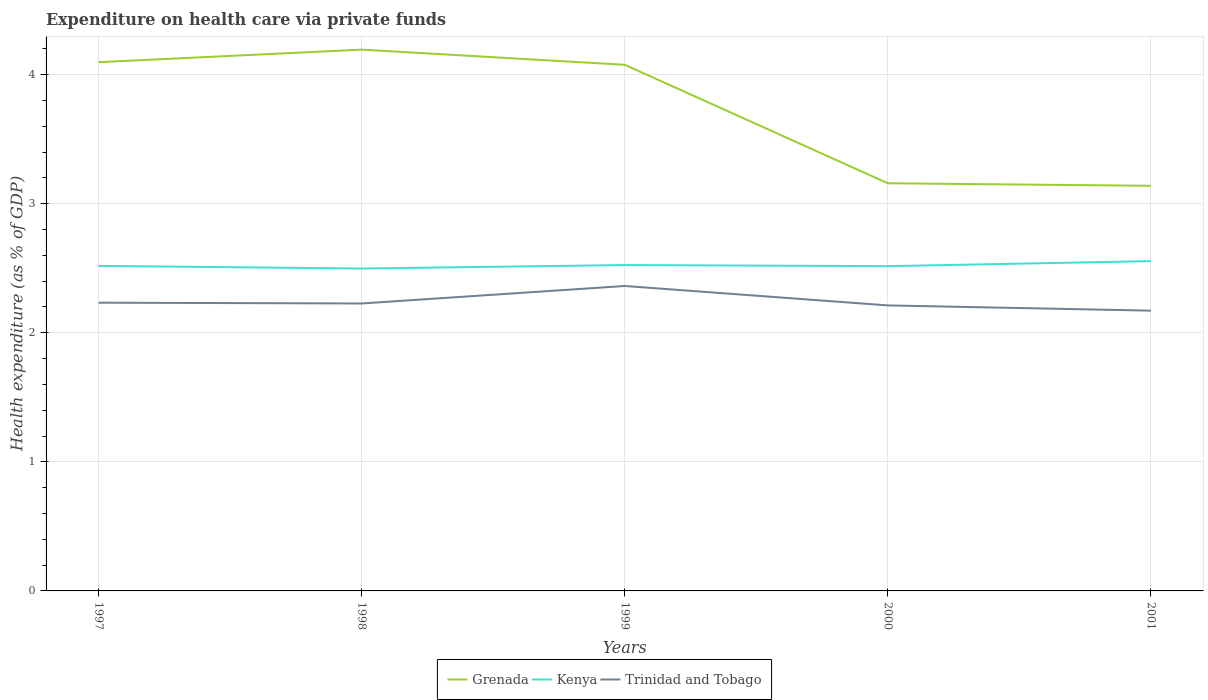Is the number of lines equal to the number of legend labels?
Offer a terse response. Yes. Across all years, what is the maximum expenditure made on health care in Grenada?
Provide a short and direct response. 3.14. In which year was the expenditure made on health care in Grenada maximum?
Make the answer very short. 2001. What is the total expenditure made on health care in Trinidad and Tobago in the graph?
Your answer should be very brief. 0.02. What is the difference between the highest and the second highest expenditure made on health care in Kenya?
Ensure brevity in your answer.  0.06. What is the difference between the highest and the lowest expenditure made on health care in Grenada?
Your response must be concise. 3. What is the difference between two consecutive major ticks on the Y-axis?
Ensure brevity in your answer.  1. Are the values on the major ticks of Y-axis written in scientific E-notation?
Your response must be concise. No. What is the title of the graph?
Your answer should be very brief. Expenditure on health care via private funds. Does "Middle income" appear as one of the legend labels in the graph?
Provide a short and direct response. No. What is the label or title of the Y-axis?
Offer a terse response. Health expenditure (as % of GDP). What is the Health expenditure (as % of GDP) of Grenada in 1997?
Offer a terse response. 4.1. What is the Health expenditure (as % of GDP) of Kenya in 1997?
Offer a terse response. 2.52. What is the Health expenditure (as % of GDP) in Trinidad and Tobago in 1997?
Keep it short and to the point. 2.23. What is the Health expenditure (as % of GDP) in Grenada in 1998?
Provide a short and direct response. 4.19. What is the Health expenditure (as % of GDP) in Kenya in 1998?
Provide a succinct answer. 2.5. What is the Health expenditure (as % of GDP) in Trinidad and Tobago in 1998?
Offer a very short reply. 2.23. What is the Health expenditure (as % of GDP) of Grenada in 1999?
Your answer should be very brief. 4.08. What is the Health expenditure (as % of GDP) in Kenya in 1999?
Make the answer very short. 2.52. What is the Health expenditure (as % of GDP) of Trinidad and Tobago in 1999?
Provide a succinct answer. 2.36. What is the Health expenditure (as % of GDP) in Grenada in 2000?
Offer a terse response. 3.16. What is the Health expenditure (as % of GDP) of Kenya in 2000?
Make the answer very short. 2.52. What is the Health expenditure (as % of GDP) in Trinidad and Tobago in 2000?
Offer a terse response. 2.21. What is the Health expenditure (as % of GDP) in Grenada in 2001?
Provide a succinct answer. 3.14. What is the Health expenditure (as % of GDP) in Kenya in 2001?
Your answer should be very brief. 2.55. What is the Health expenditure (as % of GDP) of Trinidad and Tobago in 2001?
Your answer should be compact. 2.17. Across all years, what is the maximum Health expenditure (as % of GDP) in Grenada?
Give a very brief answer. 4.19. Across all years, what is the maximum Health expenditure (as % of GDP) in Kenya?
Offer a very short reply. 2.55. Across all years, what is the maximum Health expenditure (as % of GDP) in Trinidad and Tobago?
Provide a succinct answer. 2.36. Across all years, what is the minimum Health expenditure (as % of GDP) in Grenada?
Your answer should be very brief. 3.14. Across all years, what is the minimum Health expenditure (as % of GDP) in Kenya?
Your response must be concise. 2.5. Across all years, what is the minimum Health expenditure (as % of GDP) in Trinidad and Tobago?
Ensure brevity in your answer.  2.17. What is the total Health expenditure (as % of GDP) in Grenada in the graph?
Offer a terse response. 18.66. What is the total Health expenditure (as % of GDP) in Kenya in the graph?
Make the answer very short. 12.61. What is the total Health expenditure (as % of GDP) of Trinidad and Tobago in the graph?
Your answer should be very brief. 11.21. What is the difference between the Health expenditure (as % of GDP) of Grenada in 1997 and that in 1998?
Your answer should be compact. -0.1. What is the difference between the Health expenditure (as % of GDP) in Kenya in 1997 and that in 1998?
Provide a short and direct response. 0.02. What is the difference between the Health expenditure (as % of GDP) in Trinidad and Tobago in 1997 and that in 1998?
Make the answer very short. 0.01. What is the difference between the Health expenditure (as % of GDP) of Grenada in 1997 and that in 1999?
Ensure brevity in your answer.  0.02. What is the difference between the Health expenditure (as % of GDP) of Kenya in 1997 and that in 1999?
Make the answer very short. -0.01. What is the difference between the Health expenditure (as % of GDP) of Trinidad and Tobago in 1997 and that in 1999?
Give a very brief answer. -0.13. What is the difference between the Health expenditure (as % of GDP) in Grenada in 1997 and that in 2000?
Keep it short and to the point. 0.94. What is the difference between the Health expenditure (as % of GDP) of Kenya in 1997 and that in 2000?
Ensure brevity in your answer.  0. What is the difference between the Health expenditure (as % of GDP) of Trinidad and Tobago in 1997 and that in 2000?
Your response must be concise. 0.02. What is the difference between the Health expenditure (as % of GDP) of Grenada in 1997 and that in 2001?
Provide a succinct answer. 0.96. What is the difference between the Health expenditure (as % of GDP) of Kenya in 1997 and that in 2001?
Keep it short and to the point. -0.04. What is the difference between the Health expenditure (as % of GDP) in Trinidad and Tobago in 1997 and that in 2001?
Your response must be concise. 0.06. What is the difference between the Health expenditure (as % of GDP) of Grenada in 1998 and that in 1999?
Give a very brief answer. 0.12. What is the difference between the Health expenditure (as % of GDP) of Kenya in 1998 and that in 1999?
Keep it short and to the point. -0.03. What is the difference between the Health expenditure (as % of GDP) in Trinidad and Tobago in 1998 and that in 1999?
Provide a succinct answer. -0.14. What is the difference between the Health expenditure (as % of GDP) in Grenada in 1998 and that in 2000?
Give a very brief answer. 1.04. What is the difference between the Health expenditure (as % of GDP) in Kenya in 1998 and that in 2000?
Provide a short and direct response. -0.02. What is the difference between the Health expenditure (as % of GDP) in Trinidad and Tobago in 1998 and that in 2000?
Your answer should be very brief. 0.01. What is the difference between the Health expenditure (as % of GDP) in Grenada in 1998 and that in 2001?
Provide a short and direct response. 1.05. What is the difference between the Health expenditure (as % of GDP) of Kenya in 1998 and that in 2001?
Offer a terse response. -0.06. What is the difference between the Health expenditure (as % of GDP) in Trinidad and Tobago in 1998 and that in 2001?
Your answer should be very brief. 0.06. What is the difference between the Health expenditure (as % of GDP) in Grenada in 1999 and that in 2000?
Ensure brevity in your answer.  0.92. What is the difference between the Health expenditure (as % of GDP) in Kenya in 1999 and that in 2000?
Offer a terse response. 0.01. What is the difference between the Health expenditure (as % of GDP) of Trinidad and Tobago in 1999 and that in 2000?
Provide a succinct answer. 0.15. What is the difference between the Health expenditure (as % of GDP) of Grenada in 1999 and that in 2001?
Offer a very short reply. 0.94. What is the difference between the Health expenditure (as % of GDP) in Kenya in 1999 and that in 2001?
Ensure brevity in your answer.  -0.03. What is the difference between the Health expenditure (as % of GDP) in Trinidad and Tobago in 1999 and that in 2001?
Provide a short and direct response. 0.19. What is the difference between the Health expenditure (as % of GDP) in Grenada in 2000 and that in 2001?
Your answer should be very brief. 0.02. What is the difference between the Health expenditure (as % of GDP) in Kenya in 2000 and that in 2001?
Provide a succinct answer. -0.04. What is the difference between the Health expenditure (as % of GDP) in Trinidad and Tobago in 2000 and that in 2001?
Your response must be concise. 0.04. What is the difference between the Health expenditure (as % of GDP) in Grenada in 1997 and the Health expenditure (as % of GDP) in Kenya in 1998?
Offer a terse response. 1.6. What is the difference between the Health expenditure (as % of GDP) of Grenada in 1997 and the Health expenditure (as % of GDP) of Trinidad and Tobago in 1998?
Offer a very short reply. 1.87. What is the difference between the Health expenditure (as % of GDP) in Kenya in 1997 and the Health expenditure (as % of GDP) in Trinidad and Tobago in 1998?
Keep it short and to the point. 0.29. What is the difference between the Health expenditure (as % of GDP) of Grenada in 1997 and the Health expenditure (as % of GDP) of Kenya in 1999?
Offer a terse response. 1.57. What is the difference between the Health expenditure (as % of GDP) of Grenada in 1997 and the Health expenditure (as % of GDP) of Trinidad and Tobago in 1999?
Keep it short and to the point. 1.73. What is the difference between the Health expenditure (as % of GDP) in Kenya in 1997 and the Health expenditure (as % of GDP) in Trinidad and Tobago in 1999?
Ensure brevity in your answer.  0.16. What is the difference between the Health expenditure (as % of GDP) of Grenada in 1997 and the Health expenditure (as % of GDP) of Kenya in 2000?
Offer a terse response. 1.58. What is the difference between the Health expenditure (as % of GDP) in Grenada in 1997 and the Health expenditure (as % of GDP) in Trinidad and Tobago in 2000?
Provide a succinct answer. 1.88. What is the difference between the Health expenditure (as % of GDP) of Kenya in 1997 and the Health expenditure (as % of GDP) of Trinidad and Tobago in 2000?
Your answer should be very brief. 0.31. What is the difference between the Health expenditure (as % of GDP) of Grenada in 1997 and the Health expenditure (as % of GDP) of Kenya in 2001?
Make the answer very short. 1.54. What is the difference between the Health expenditure (as % of GDP) in Grenada in 1997 and the Health expenditure (as % of GDP) in Trinidad and Tobago in 2001?
Your response must be concise. 1.92. What is the difference between the Health expenditure (as % of GDP) in Kenya in 1997 and the Health expenditure (as % of GDP) in Trinidad and Tobago in 2001?
Offer a terse response. 0.35. What is the difference between the Health expenditure (as % of GDP) in Grenada in 1998 and the Health expenditure (as % of GDP) in Kenya in 1999?
Keep it short and to the point. 1.67. What is the difference between the Health expenditure (as % of GDP) in Grenada in 1998 and the Health expenditure (as % of GDP) in Trinidad and Tobago in 1999?
Your response must be concise. 1.83. What is the difference between the Health expenditure (as % of GDP) of Kenya in 1998 and the Health expenditure (as % of GDP) of Trinidad and Tobago in 1999?
Ensure brevity in your answer.  0.14. What is the difference between the Health expenditure (as % of GDP) of Grenada in 1998 and the Health expenditure (as % of GDP) of Kenya in 2000?
Your answer should be compact. 1.68. What is the difference between the Health expenditure (as % of GDP) of Grenada in 1998 and the Health expenditure (as % of GDP) of Trinidad and Tobago in 2000?
Your response must be concise. 1.98. What is the difference between the Health expenditure (as % of GDP) of Kenya in 1998 and the Health expenditure (as % of GDP) of Trinidad and Tobago in 2000?
Offer a terse response. 0.29. What is the difference between the Health expenditure (as % of GDP) of Grenada in 1998 and the Health expenditure (as % of GDP) of Kenya in 2001?
Give a very brief answer. 1.64. What is the difference between the Health expenditure (as % of GDP) in Grenada in 1998 and the Health expenditure (as % of GDP) in Trinidad and Tobago in 2001?
Provide a succinct answer. 2.02. What is the difference between the Health expenditure (as % of GDP) of Kenya in 1998 and the Health expenditure (as % of GDP) of Trinidad and Tobago in 2001?
Provide a short and direct response. 0.33. What is the difference between the Health expenditure (as % of GDP) in Grenada in 1999 and the Health expenditure (as % of GDP) in Kenya in 2000?
Your response must be concise. 1.56. What is the difference between the Health expenditure (as % of GDP) in Grenada in 1999 and the Health expenditure (as % of GDP) in Trinidad and Tobago in 2000?
Make the answer very short. 1.86. What is the difference between the Health expenditure (as % of GDP) of Kenya in 1999 and the Health expenditure (as % of GDP) of Trinidad and Tobago in 2000?
Keep it short and to the point. 0.31. What is the difference between the Health expenditure (as % of GDP) in Grenada in 1999 and the Health expenditure (as % of GDP) in Kenya in 2001?
Provide a short and direct response. 1.52. What is the difference between the Health expenditure (as % of GDP) of Grenada in 1999 and the Health expenditure (as % of GDP) of Trinidad and Tobago in 2001?
Keep it short and to the point. 1.9. What is the difference between the Health expenditure (as % of GDP) of Kenya in 1999 and the Health expenditure (as % of GDP) of Trinidad and Tobago in 2001?
Keep it short and to the point. 0.35. What is the difference between the Health expenditure (as % of GDP) of Grenada in 2000 and the Health expenditure (as % of GDP) of Kenya in 2001?
Make the answer very short. 0.6. What is the difference between the Health expenditure (as % of GDP) of Kenya in 2000 and the Health expenditure (as % of GDP) of Trinidad and Tobago in 2001?
Provide a short and direct response. 0.34. What is the average Health expenditure (as % of GDP) in Grenada per year?
Provide a short and direct response. 3.73. What is the average Health expenditure (as % of GDP) of Kenya per year?
Provide a succinct answer. 2.52. What is the average Health expenditure (as % of GDP) in Trinidad and Tobago per year?
Your answer should be compact. 2.24. In the year 1997, what is the difference between the Health expenditure (as % of GDP) of Grenada and Health expenditure (as % of GDP) of Kenya?
Provide a succinct answer. 1.58. In the year 1997, what is the difference between the Health expenditure (as % of GDP) in Grenada and Health expenditure (as % of GDP) in Trinidad and Tobago?
Make the answer very short. 1.86. In the year 1997, what is the difference between the Health expenditure (as % of GDP) in Kenya and Health expenditure (as % of GDP) in Trinidad and Tobago?
Make the answer very short. 0.28. In the year 1998, what is the difference between the Health expenditure (as % of GDP) of Grenada and Health expenditure (as % of GDP) of Kenya?
Give a very brief answer. 1.7. In the year 1998, what is the difference between the Health expenditure (as % of GDP) in Grenada and Health expenditure (as % of GDP) in Trinidad and Tobago?
Provide a succinct answer. 1.97. In the year 1998, what is the difference between the Health expenditure (as % of GDP) in Kenya and Health expenditure (as % of GDP) in Trinidad and Tobago?
Your answer should be very brief. 0.27. In the year 1999, what is the difference between the Health expenditure (as % of GDP) in Grenada and Health expenditure (as % of GDP) in Kenya?
Your answer should be compact. 1.55. In the year 1999, what is the difference between the Health expenditure (as % of GDP) in Grenada and Health expenditure (as % of GDP) in Trinidad and Tobago?
Offer a terse response. 1.71. In the year 1999, what is the difference between the Health expenditure (as % of GDP) in Kenya and Health expenditure (as % of GDP) in Trinidad and Tobago?
Your answer should be compact. 0.16. In the year 2000, what is the difference between the Health expenditure (as % of GDP) in Grenada and Health expenditure (as % of GDP) in Kenya?
Give a very brief answer. 0.64. In the year 2000, what is the difference between the Health expenditure (as % of GDP) in Grenada and Health expenditure (as % of GDP) in Trinidad and Tobago?
Provide a short and direct response. 0.95. In the year 2000, what is the difference between the Health expenditure (as % of GDP) of Kenya and Health expenditure (as % of GDP) of Trinidad and Tobago?
Ensure brevity in your answer.  0.3. In the year 2001, what is the difference between the Health expenditure (as % of GDP) of Grenada and Health expenditure (as % of GDP) of Kenya?
Provide a short and direct response. 0.58. In the year 2001, what is the difference between the Health expenditure (as % of GDP) in Grenada and Health expenditure (as % of GDP) in Trinidad and Tobago?
Ensure brevity in your answer.  0.97. In the year 2001, what is the difference between the Health expenditure (as % of GDP) in Kenya and Health expenditure (as % of GDP) in Trinidad and Tobago?
Your answer should be very brief. 0.38. What is the ratio of the Health expenditure (as % of GDP) of Grenada in 1997 to that in 1998?
Offer a terse response. 0.98. What is the ratio of the Health expenditure (as % of GDP) in Grenada in 1997 to that in 1999?
Your response must be concise. 1. What is the ratio of the Health expenditure (as % of GDP) of Kenya in 1997 to that in 1999?
Your answer should be compact. 1. What is the ratio of the Health expenditure (as % of GDP) in Trinidad and Tobago in 1997 to that in 1999?
Make the answer very short. 0.95. What is the ratio of the Health expenditure (as % of GDP) in Grenada in 1997 to that in 2000?
Your answer should be very brief. 1.3. What is the ratio of the Health expenditure (as % of GDP) of Kenya in 1997 to that in 2000?
Your answer should be compact. 1. What is the ratio of the Health expenditure (as % of GDP) in Trinidad and Tobago in 1997 to that in 2000?
Provide a short and direct response. 1.01. What is the ratio of the Health expenditure (as % of GDP) of Grenada in 1997 to that in 2001?
Provide a succinct answer. 1.31. What is the ratio of the Health expenditure (as % of GDP) in Kenya in 1997 to that in 2001?
Provide a short and direct response. 0.99. What is the ratio of the Health expenditure (as % of GDP) in Trinidad and Tobago in 1997 to that in 2001?
Provide a succinct answer. 1.03. What is the ratio of the Health expenditure (as % of GDP) in Grenada in 1998 to that in 1999?
Offer a very short reply. 1.03. What is the ratio of the Health expenditure (as % of GDP) of Kenya in 1998 to that in 1999?
Make the answer very short. 0.99. What is the ratio of the Health expenditure (as % of GDP) of Trinidad and Tobago in 1998 to that in 1999?
Your response must be concise. 0.94. What is the ratio of the Health expenditure (as % of GDP) of Grenada in 1998 to that in 2000?
Your response must be concise. 1.33. What is the ratio of the Health expenditure (as % of GDP) in Kenya in 1998 to that in 2000?
Ensure brevity in your answer.  0.99. What is the ratio of the Health expenditure (as % of GDP) of Trinidad and Tobago in 1998 to that in 2000?
Make the answer very short. 1.01. What is the ratio of the Health expenditure (as % of GDP) in Grenada in 1998 to that in 2001?
Keep it short and to the point. 1.34. What is the ratio of the Health expenditure (as % of GDP) in Kenya in 1998 to that in 2001?
Ensure brevity in your answer.  0.98. What is the ratio of the Health expenditure (as % of GDP) in Trinidad and Tobago in 1998 to that in 2001?
Make the answer very short. 1.03. What is the ratio of the Health expenditure (as % of GDP) in Grenada in 1999 to that in 2000?
Give a very brief answer. 1.29. What is the ratio of the Health expenditure (as % of GDP) in Kenya in 1999 to that in 2000?
Offer a terse response. 1. What is the ratio of the Health expenditure (as % of GDP) of Trinidad and Tobago in 1999 to that in 2000?
Make the answer very short. 1.07. What is the ratio of the Health expenditure (as % of GDP) in Grenada in 1999 to that in 2001?
Give a very brief answer. 1.3. What is the ratio of the Health expenditure (as % of GDP) in Trinidad and Tobago in 1999 to that in 2001?
Make the answer very short. 1.09. What is the ratio of the Health expenditure (as % of GDP) in Grenada in 2000 to that in 2001?
Ensure brevity in your answer.  1.01. What is the ratio of the Health expenditure (as % of GDP) of Kenya in 2000 to that in 2001?
Make the answer very short. 0.98. What is the ratio of the Health expenditure (as % of GDP) of Trinidad and Tobago in 2000 to that in 2001?
Give a very brief answer. 1.02. What is the difference between the highest and the second highest Health expenditure (as % of GDP) in Grenada?
Offer a terse response. 0.1. What is the difference between the highest and the second highest Health expenditure (as % of GDP) in Kenya?
Your answer should be compact. 0.03. What is the difference between the highest and the second highest Health expenditure (as % of GDP) of Trinidad and Tobago?
Provide a short and direct response. 0.13. What is the difference between the highest and the lowest Health expenditure (as % of GDP) in Grenada?
Provide a short and direct response. 1.05. What is the difference between the highest and the lowest Health expenditure (as % of GDP) in Kenya?
Make the answer very short. 0.06. What is the difference between the highest and the lowest Health expenditure (as % of GDP) in Trinidad and Tobago?
Provide a succinct answer. 0.19. 